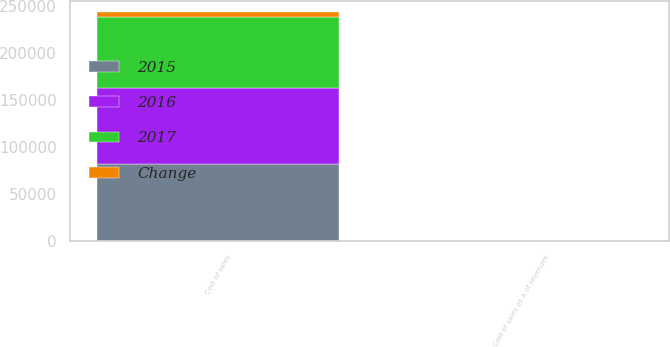Convert chart. <chart><loc_0><loc_0><loc_500><loc_500><stacked_bar_chart><ecel><fcel>Cost of sales<fcel>Cost of sales as a of revenues<nl><fcel>2017<fcel>76066<fcel>81.4<nl><fcel>2016<fcel>80790<fcel>85.4<nl><fcel>Change<fcel>4724<fcel>4<nl><fcel>2015<fcel>82088<fcel>85.4<nl></chart> 